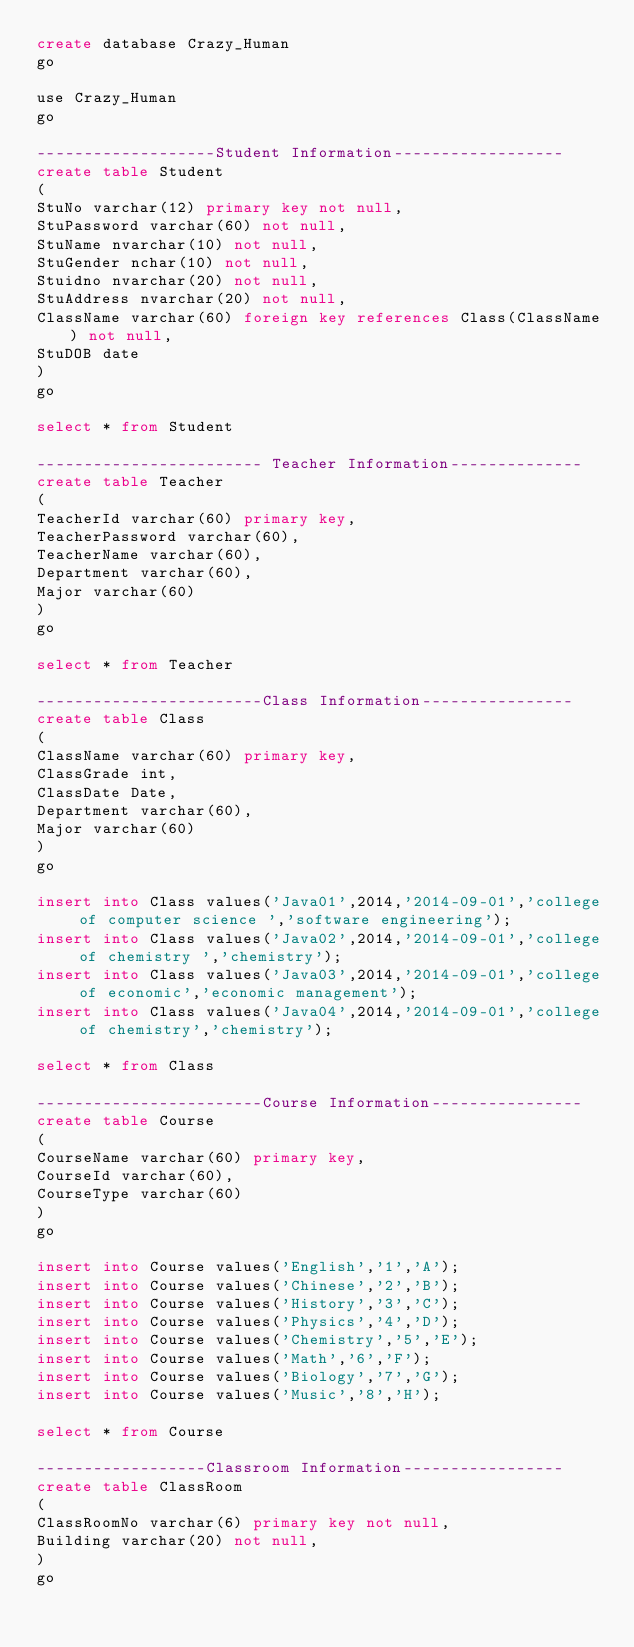<code> <loc_0><loc_0><loc_500><loc_500><_SQL_>create database Crazy_Human
go

use Crazy_Human
go

-------------------Student Information------------------
create table Student
(
StuNo varchar(12) primary key not null,
StuPassword varchar(60) not null,
StuName nvarchar(10) not null,
StuGender nchar(10) not null,
Stuidno nvarchar(20) not null,
StuAddress nvarchar(20) not null,
ClassName varchar(60) foreign key references Class(ClassName) not null,
StuDOB date
)
go

select * from Student

------------------------ Teacher Information--------------
create table Teacher 
(
TeacherId varchar(60) primary key,
TeacherPassword varchar(60),
TeacherName varchar(60),
Department varchar(60),
Major varchar(60)
)
go

select * from Teacher

------------------------Class Information----------------
create table Class
(
ClassName varchar(60) primary key,
ClassGrade int,
ClassDate Date,
Department varchar(60),
Major varchar(60)
)
go

insert into Class values('Java01',2014,'2014-09-01','college of computer science ','software engineering');
insert into Class values('Java02',2014,'2014-09-01','college of chemistry ','chemistry');
insert into Class values('Java03',2014,'2014-09-01','college of economic','economic management');
insert into Class values('Java04',2014,'2014-09-01','college of chemistry','chemistry');

select * from Class

------------------------Course Information----------------
create table Course
(
CourseName varchar(60) primary key,
CourseId varchar(60),
CourseType varchar(60)
)
go

insert into Course values('English','1','A');
insert into Course values('Chinese','2','B');
insert into Course values('History','3','C');
insert into Course values('Physics','4','D');
insert into Course values('Chemistry','5','E');
insert into Course values('Math','6','F');
insert into Course values('Biology','7','G');
insert into Course values('Music','8','H');

select * from Course

------------------Classroom Information-----------------
create table ClassRoom
(
ClassRoomNo varchar(6) primary key not null,
Building varchar(20) not null,
)
go</code> 